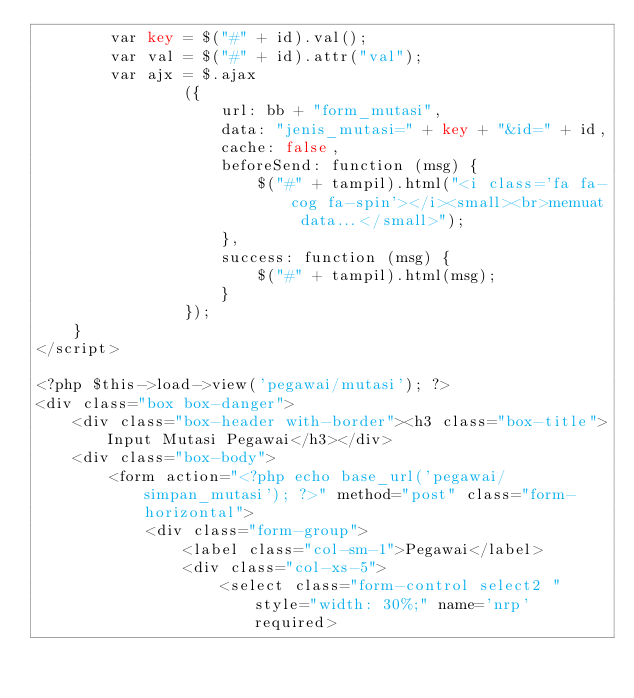<code> <loc_0><loc_0><loc_500><loc_500><_PHP_>		var key = $("#" + id).val();
		var val = $("#" + id).attr("val");
		var ajx = $.ajax
				({
					url: bb + "form_mutasi", 
					data: "jenis_mutasi=" + key + "&id=" + id,
					cache: false,
					beforeSend: function (msg) {
						$("#" + tampil).html("<i class='fa fa-cog fa-spin'></i><small><br>memuat data...</small>");
					},
					success: function (msg) {
						$("#" + tampil).html(msg);
					}
				});
	}
</script>

<?php $this->load->view('pegawai/mutasi'); ?>
<div class="box box-danger">
    <div class="box-header with-border"><h3 class="box-title">Input Mutasi Pegawai</h3></div>
	<div class="box-body">
		<form action="<?php echo base_url('pegawai/simpan_mutasi'); ?>" method="post" class="form-horizontal">
			<div class="form-group">
				<label class="col-sm-1">Pegawai</label>
				<div class="col-xs-5">
					<select class="form-control select2 " style="width: 30%;" name='nrp' required></code> 